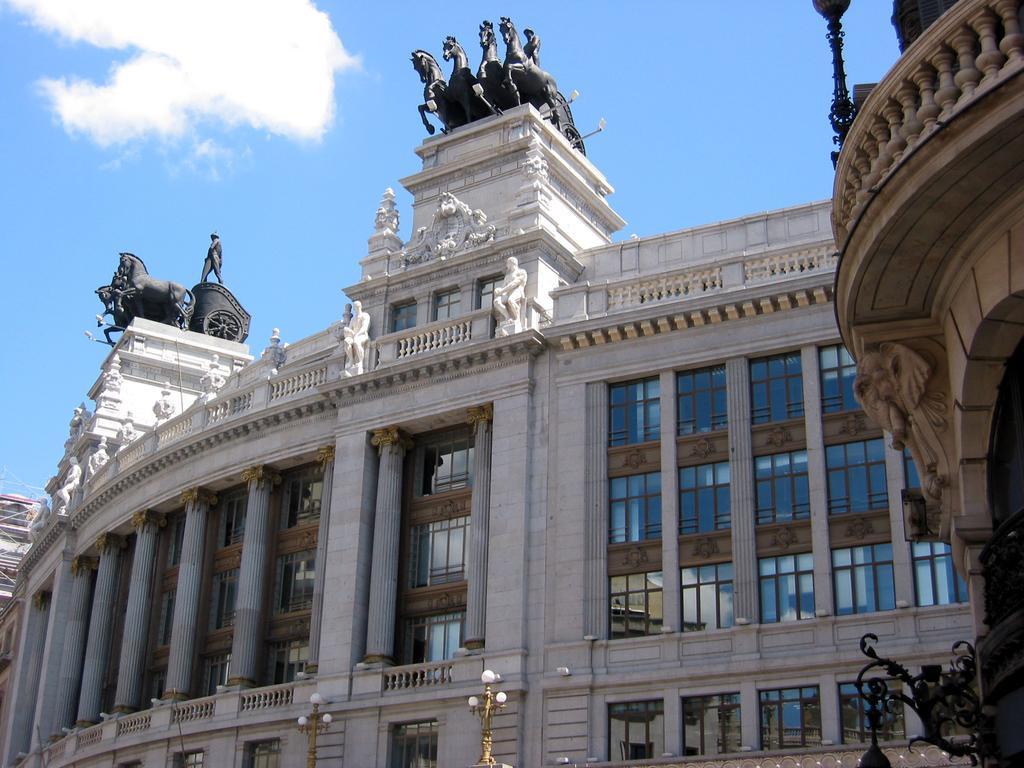Please provide a concise description of this image. In this image we can see a building, statues, pillars, street lights, grills, windows and sky with clouds. 